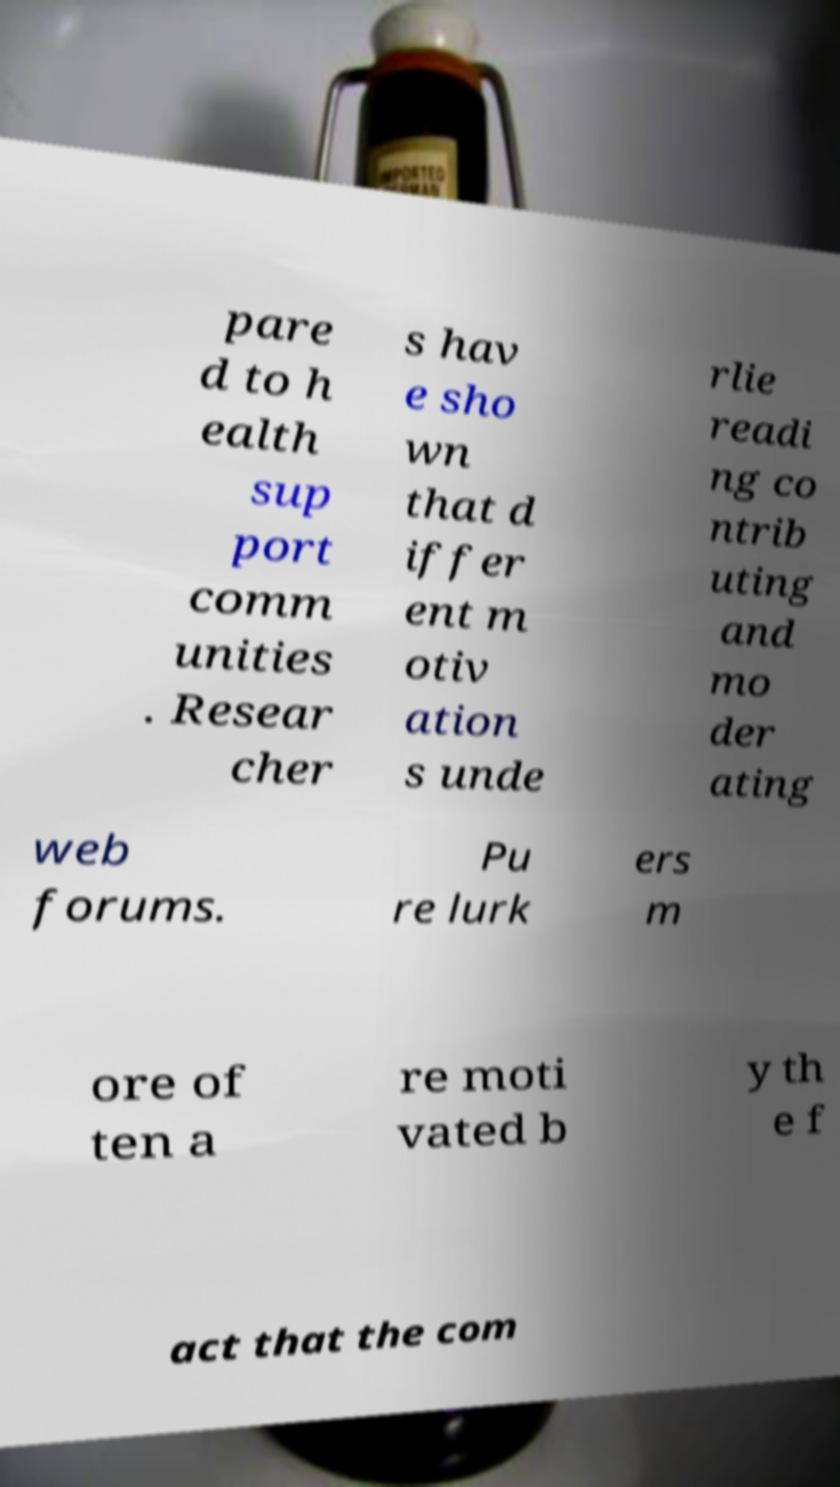Please identify and transcribe the text found in this image. pare d to h ealth sup port comm unities . Resear cher s hav e sho wn that d iffer ent m otiv ation s unde rlie readi ng co ntrib uting and mo der ating web forums. Pu re lurk ers m ore of ten a re moti vated b y th e f act that the com 